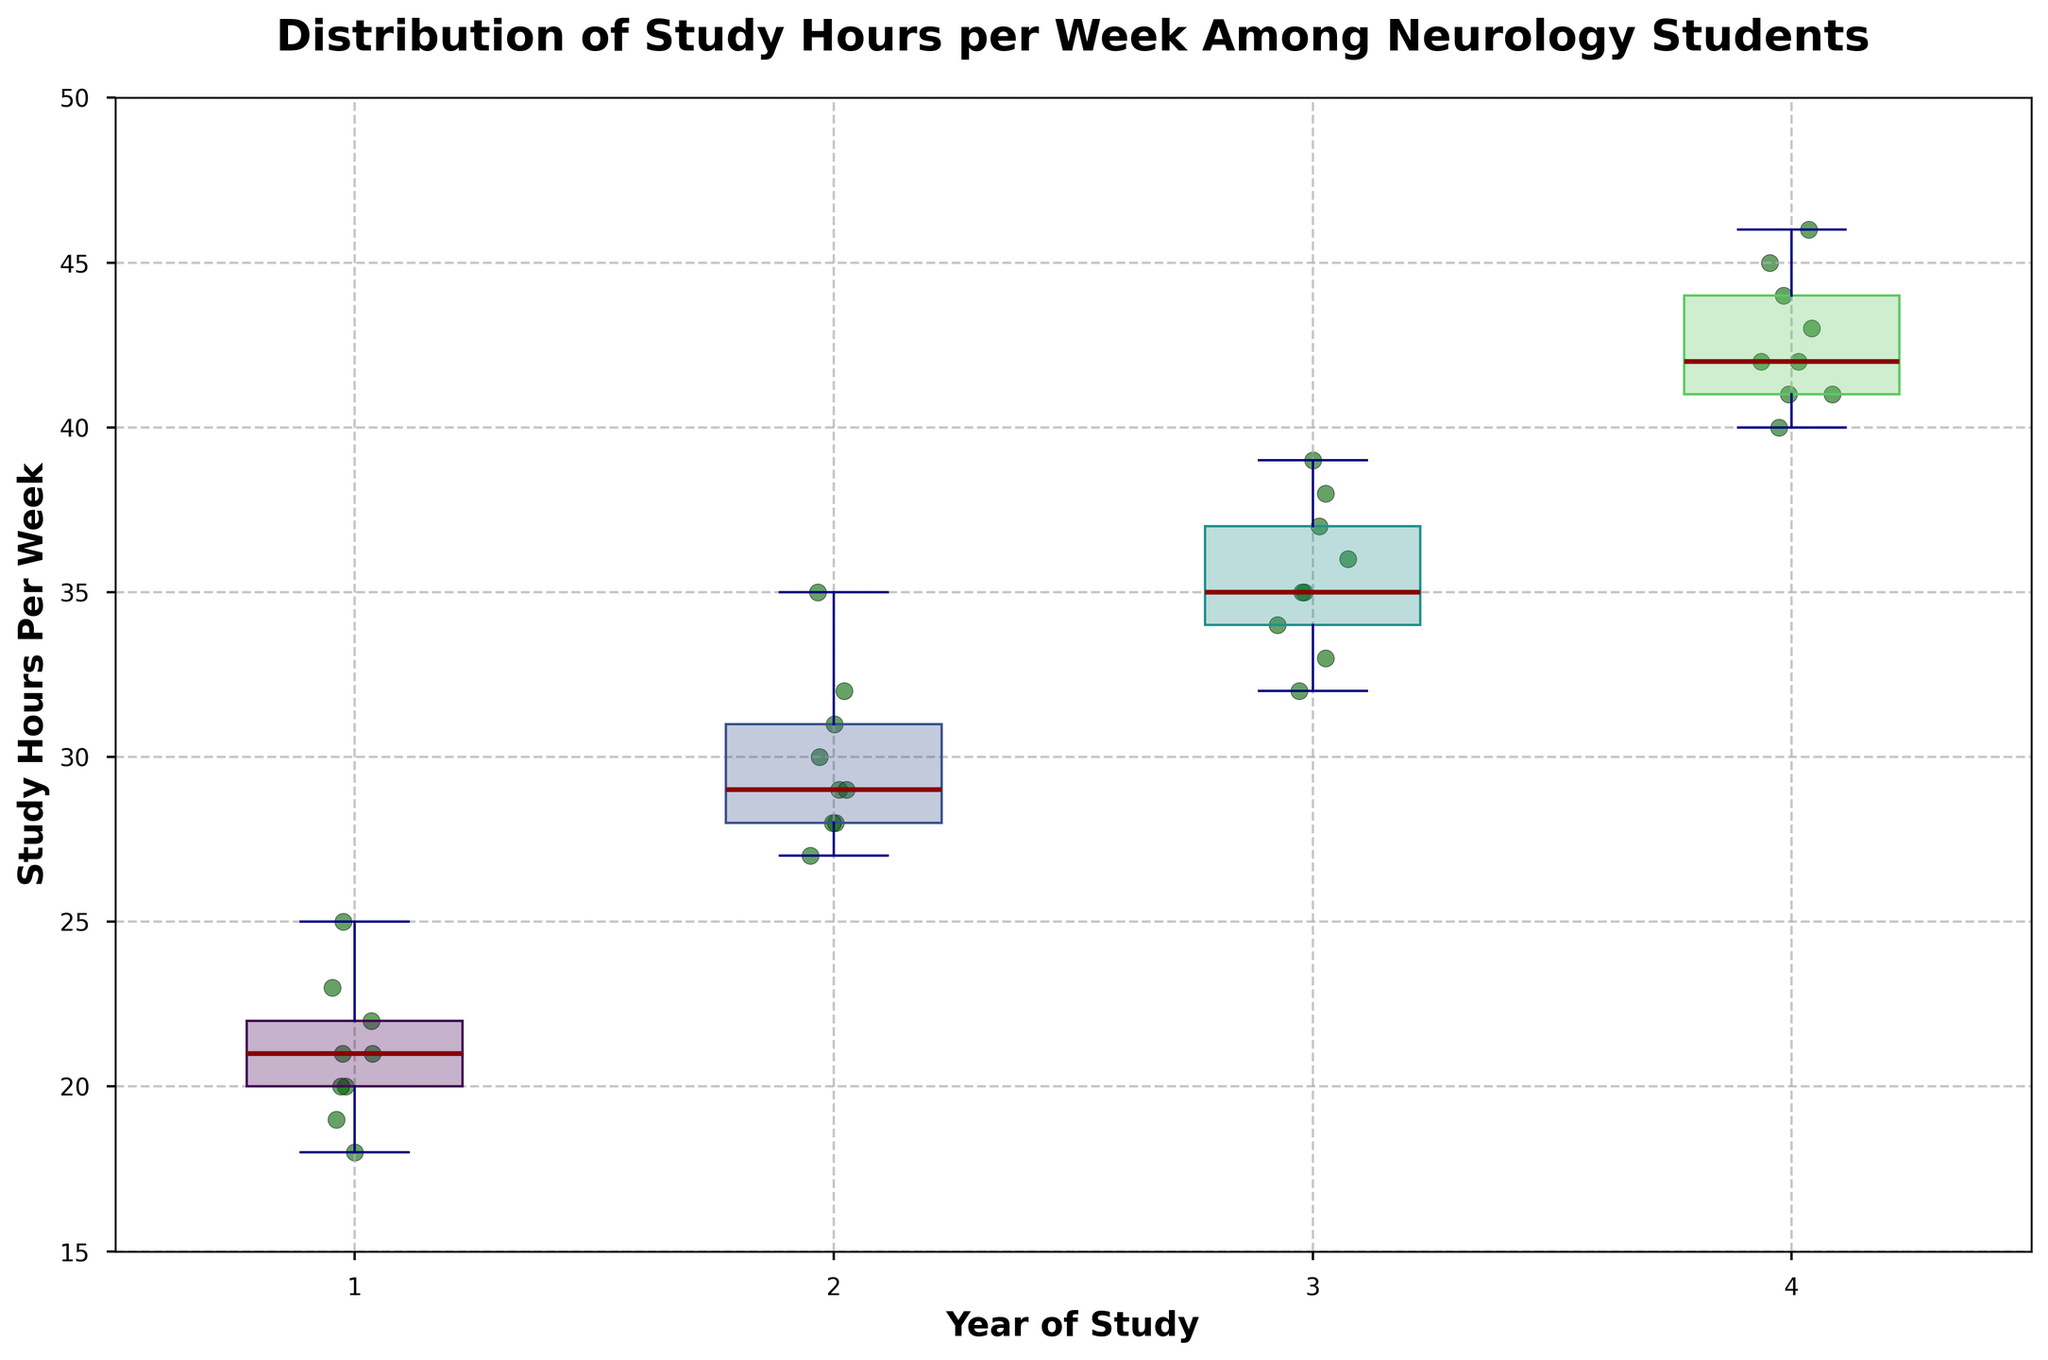What is the title of the figure? The title is typically the text displayed at the top center of the figure. In this case, the title "Distribution of Study Hours per Week Among Neurology Students" is shown prominently.
Answer: Distribution of Study Hours per Week Among Neurology Students What is the median study hours per week for first-year students? The median can be found by looking at the dark red line inside the box for each year of study. For first-year students, this line is at 20.
Answer: 20 How do the median study hours change from first-year to fourth-year students? By comparing the dark red lines in the boxes from first-year to fourth-year, we can track the median study hours. The first-year median is 20 hours, and the fourth-year median is 42 hours, indicating an increase of 22 hours.
Answer: Increase by 22 hours Which year of study has the highest variability in study hours? The variability can be judged by the length of the whiskers and the spread of the scatter points. The fourth-year students' boxplot shows the widest spread, from about 40 to 46 hours per week.
Answer: Fourth-year Are there any outliers in the study hours for third-year students? Outliers are typically displayed as individual points outside the whiskers in a box plot. In the case of third-year students, there are no individual points beyond the whiskers.
Answer: No How do the median study hours for second-year students compare to third-year students? The median for second-year students is 29 hours, while for third-year students, it is 35 hours. Thus, the median for third-year students is higher by 6 hours.
Answer: Higher by 6 hours What is the range of study hours for the second-year students? The range is determined by the difference between the maximum and minimum whisker values. For second-year students, it ranges from 27 to 35 hours, giving a range of 8 hours.
Answer: 8 hours Which year of study appears to have the most concentrated study hours around the median? Concentration around the median can be observed by how closely the points cluster around it. First-year students show a tighter clustering around the median of 20 hours.
Answer: First-year What is the interquartile range (IQR) for fourth-year students? The IQR is measured by the length of the box, which spans from the 25th percentile to the 75th percentile. For fourth-year students, the study hours range from 41 to 44, resulting in an IQR of 3 hours.
Answer: 3 hours How does the median study hours for every subsequent year compare to the previous year? Checking the median for each year: 
First-year is 20 hours, 
Second-year is 29 hours, 
Third-year is 35 hours, 
Fourth-year is 42 hours. 
Each year shows a clear increase, with the differences being 9, 6, and 7 hours, respectively.
Answer: Increase (9, 6, 7 hours) 